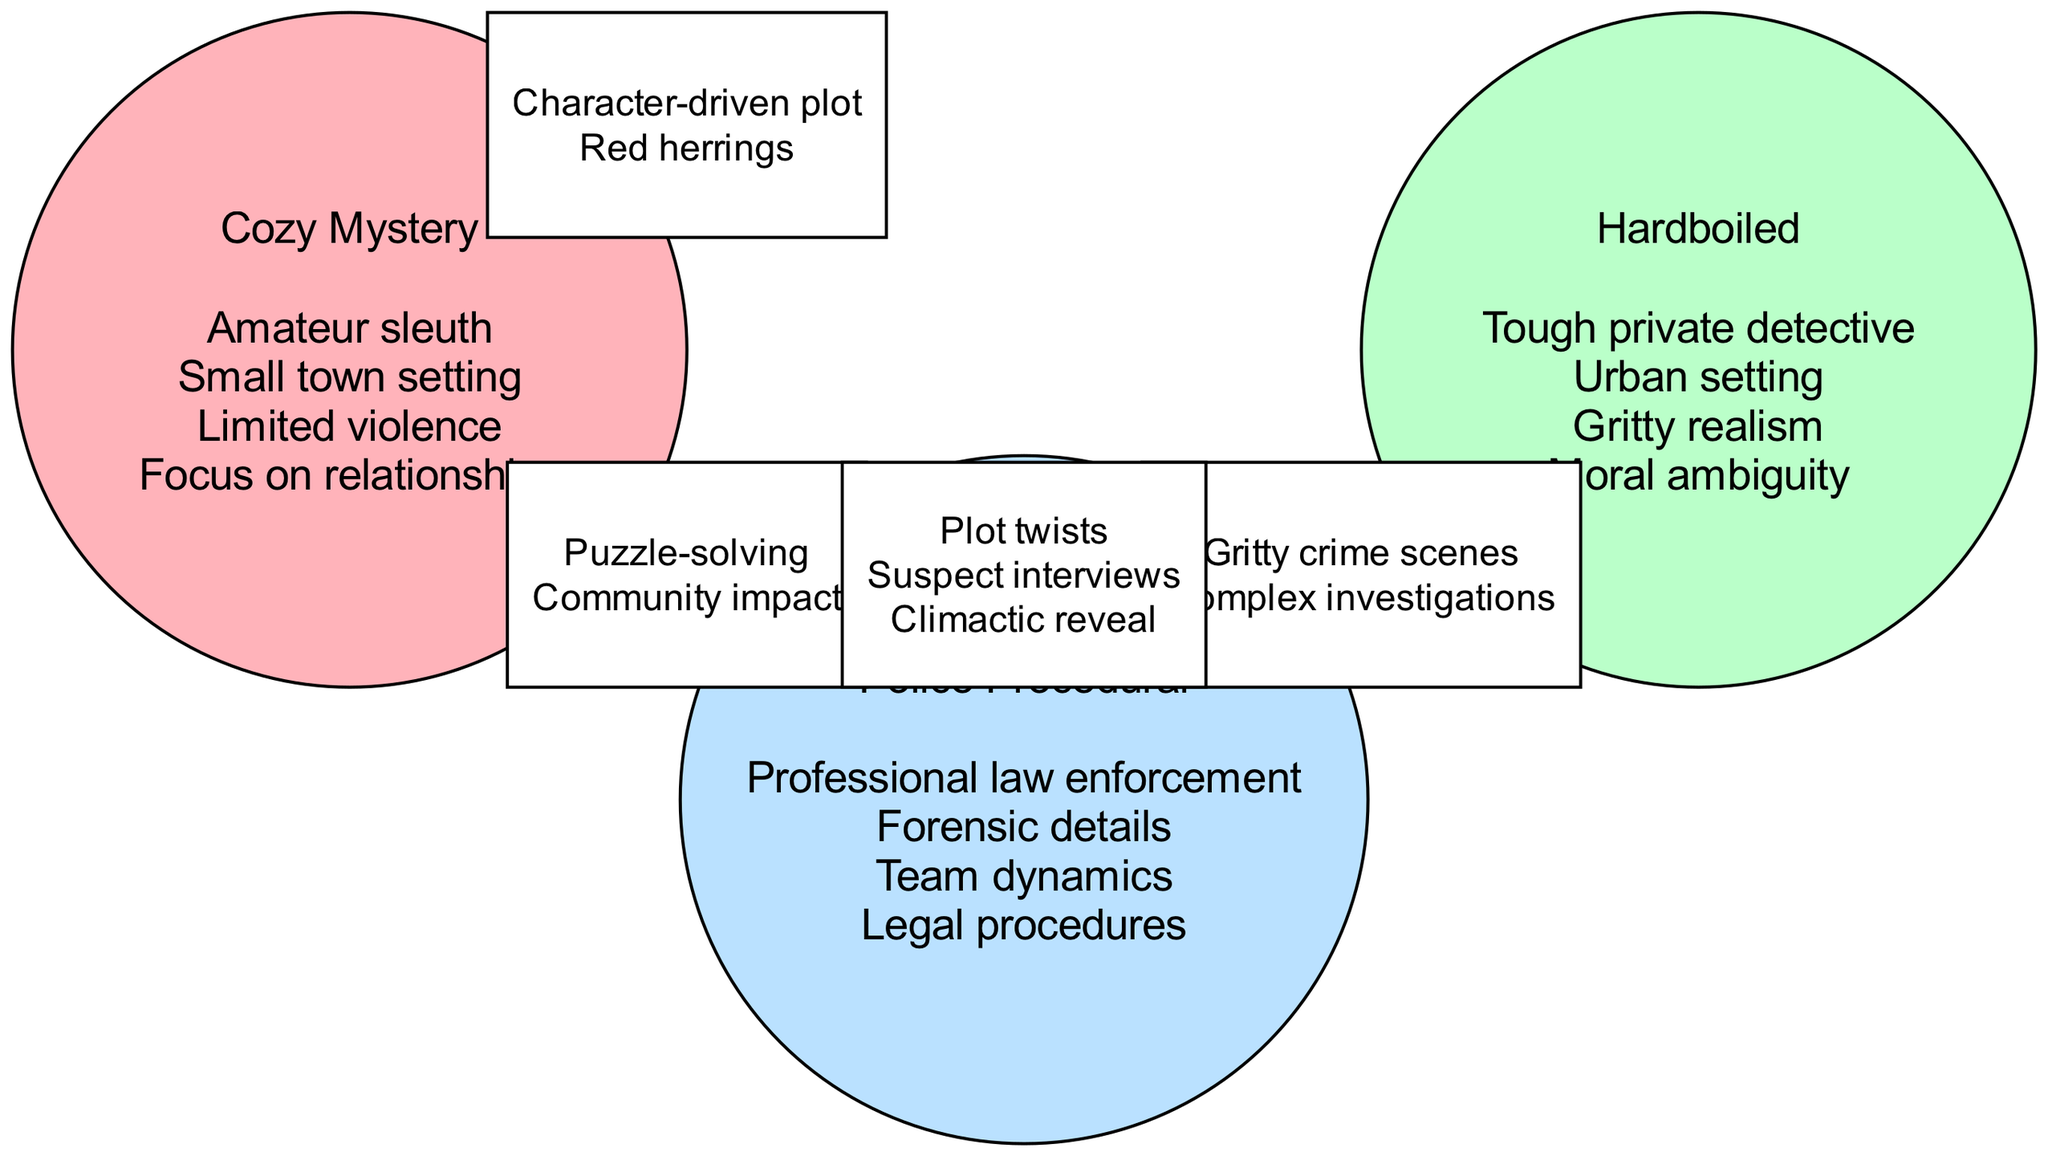What elements are unique to Cozy Mystery? To identify unique elements to Cozy Mystery, we look at the elements listed only in the Cozy Mystery section of the diagram. The elements are: amateur sleuth, small town setting, limited violence, focus on relationships.
Answer: Amateur sleuth, small town setting, limited violence, focus on relationships Which writing style includes moral ambiguity? The diagram shows that moral ambiguity is listed as an element under Hardboiled. Therefore, Hardboiled is the writing style that includes this element.
Answer: Hardboiled How many elements are shared between Cozy Mystery and Police Procedural? The diagram shows two elements shared between the Cozy Mystery and Police Procedural sections: puzzle-solving and community impact. Thus, the number of shared elements is two.
Answer: 2 What is the common feature among all three writing styles? The intersection of all three styles shows elements that belong to Cozy Mystery, Hardboiled, and Police Procedural, which are plot twists, suspect interviews, and climactic reveal. This indicates these features are common across all three styles.
Answer: Plot twists, suspect interviews, climactic reveal How many total unique elements are listed in the Venn diagram? To find the total unique elements, we count elements from all three writing styles and subtract any overlapping elements. Cozy Mystery has four elements, Hardboiled has four, Police Procedural has four, and intersections account for shared elements. After considering overlaps, the total unique elements remain different.
Answer: 10 